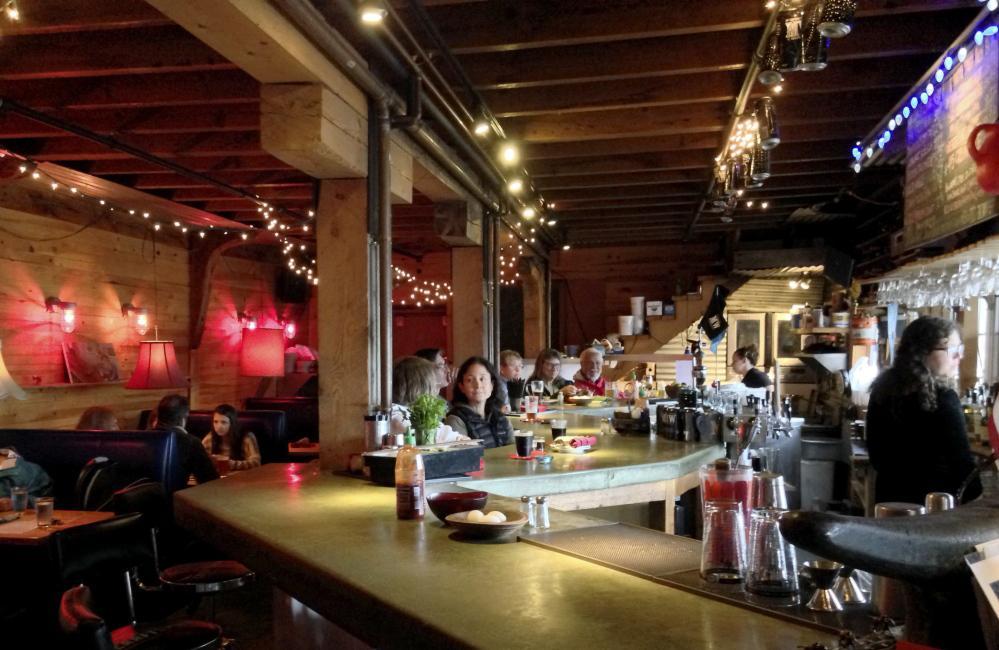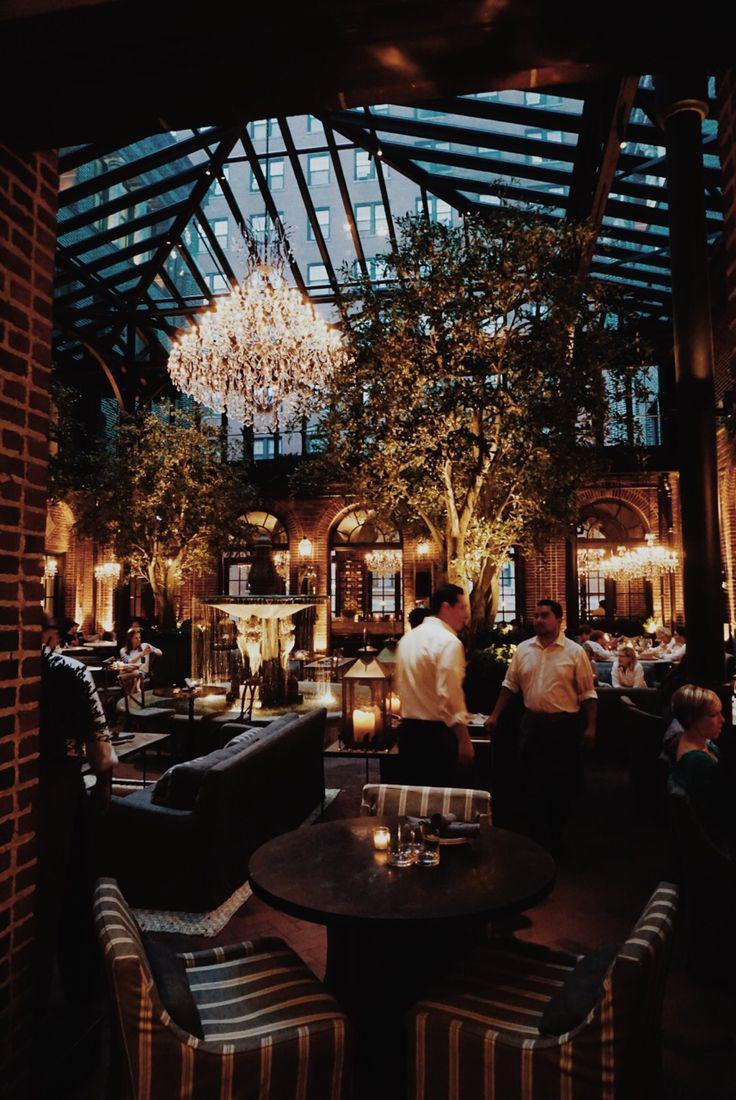The first image is the image on the left, the second image is the image on the right. Examine the images to the left and right. Is the description "One image is of the inside of a business and the other is of the outside of a business." accurate? Answer yes or no. No. The first image is the image on the left, the second image is the image on the right. For the images displayed, is the sentence "In at least one image there are bar supplies on a wooden two tone bar with the top being dark brown." factually correct? Answer yes or no. No. 